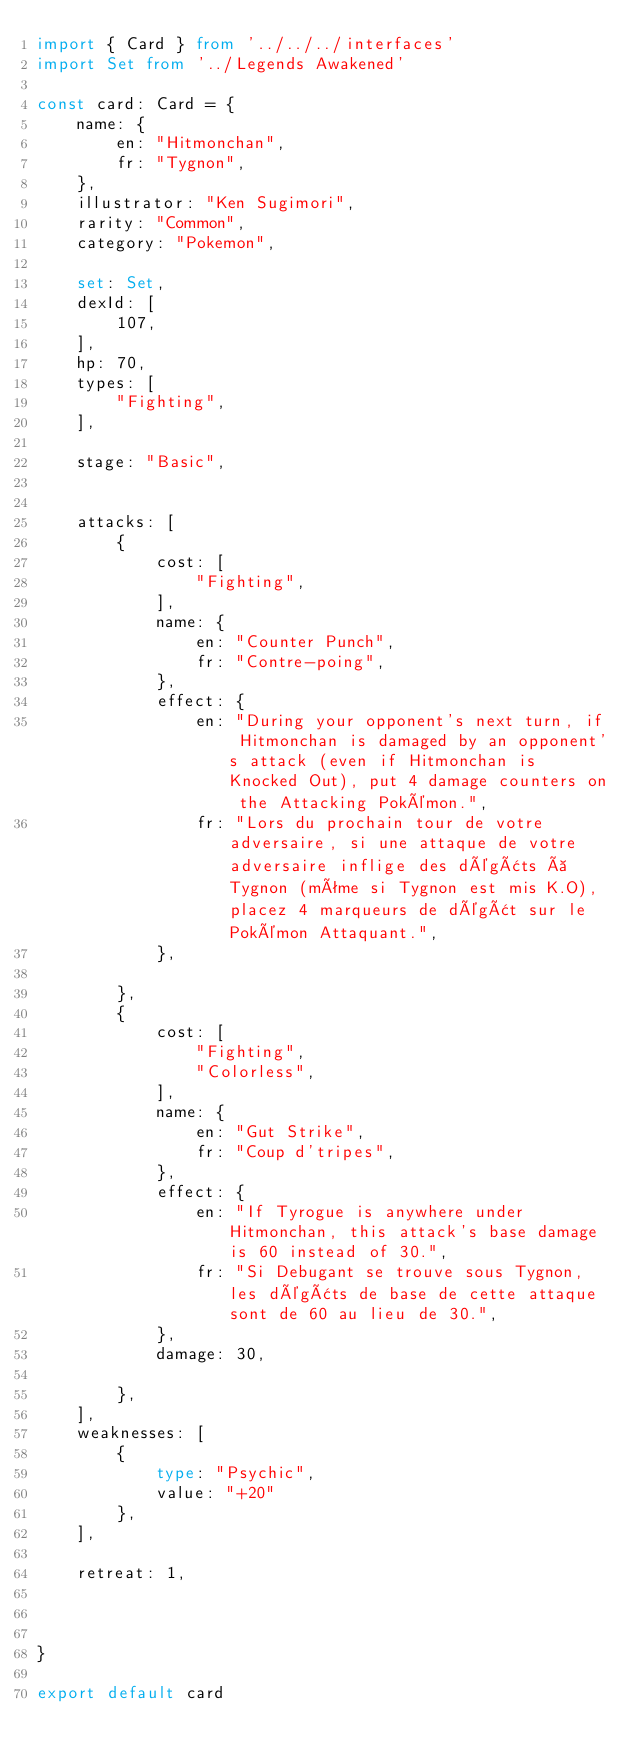<code> <loc_0><loc_0><loc_500><loc_500><_TypeScript_>import { Card } from '../../../interfaces'
import Set from '../Legends Awakened'

const card: Card = {
	name: {
		en: "Hitmonchan",
		fr: "Tygnon",
	},
	illustrator: "Ken Sugimori",
	rarity: "Common",
	category: "Pokemon",

	set: Set,
	dexId: [
		107,
	],
	hp: 70,
	types: [
		"Fighting",
	],

	stage: "Basic",


	attacks: [
		{
			cost: [
				"Fighting",
			],
			name: {
				en: "Counter Punch",
				fr: "Contre-poing",
			},
			effect: {
				en: "During your opponent's next turn, if Hitmonchan is damaged by an opponent's attack (even if Hitmonchan is Knocked Out), put 4 damage counters on the Attacking Pokémon.",
				fr: "Lors du prochain tour de votre adversaire, si une attaque de votre adversaire inflige des dégâts à Tygnon (même si Tygnon est mis K.O), placez 4 marqueurs de dégât sur le Pokémon Attaquant.",
			},

		},
		{
			cost: [
				"Fighting",
				"Colorless",
			],
			name: {
				en: "Gut Strike",
				fr: "Coup d'tripes",
			},
			effect: {
				en: "If Tyrogue is anywhere under Hitmonchan, this attack's base damage is 60 instead of 30.",
				fr: "Si Debugant se trouve sous Tygnon, les dégâts de base de cette attaque sont de 60 au lieu de 30.",
			},
			damage: 30,

		},
	],
	weaknesses: [
		{
			type: "Psychic",
			value: "+20"
		},
	],

	retreat: 1,



}

export default card
</code> 